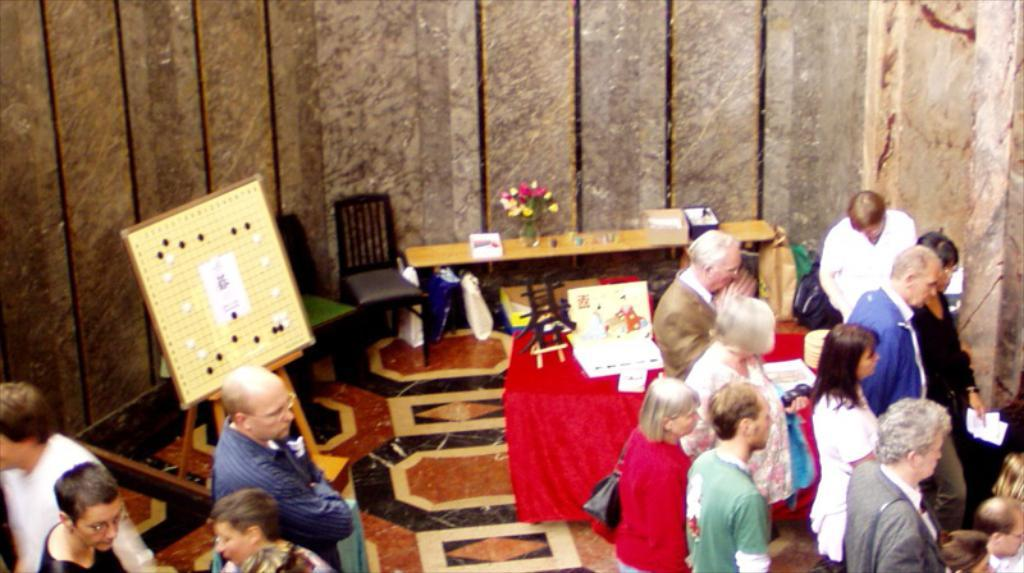What can be seen in the image involving a group of people? There is a group of people standing in the image. What type of decorative item is present in the image? There is a flower vase in the image. What furniture pieces are visible in the image? There are chairs in the image. What objects are placed on tables in the image? There are objects on the tables in the image. What kind of structure is present in the image for displaying information? There is a board with a stand in the image. Can you see a knot tied on the board in the image? There is no mention of a knot in the image, so it cannot be determined if one is present. How many owls are sitting on the chairs in the image? There is no mention of owls in the image, so it cannot be determined if any are present. 